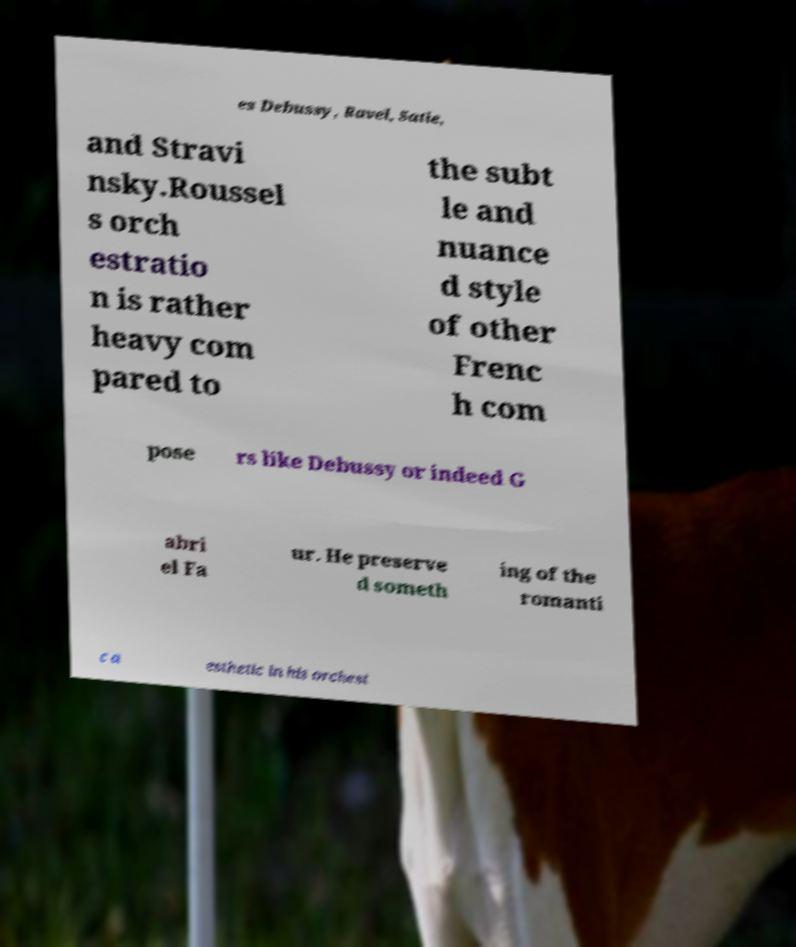What messages or text are displayed in this image? I need them in a readable, typed format. es Debussy, Ravel, Satie, and Stravi nsky.Roussel s orch estratio n is rather heavy com pared to the subt le and nuance d style of other Frenc h com pose rs like Debussy or indeed G abri el Fa ur. He preserve d someth ing of the romanti c a esthetic in his orchest 